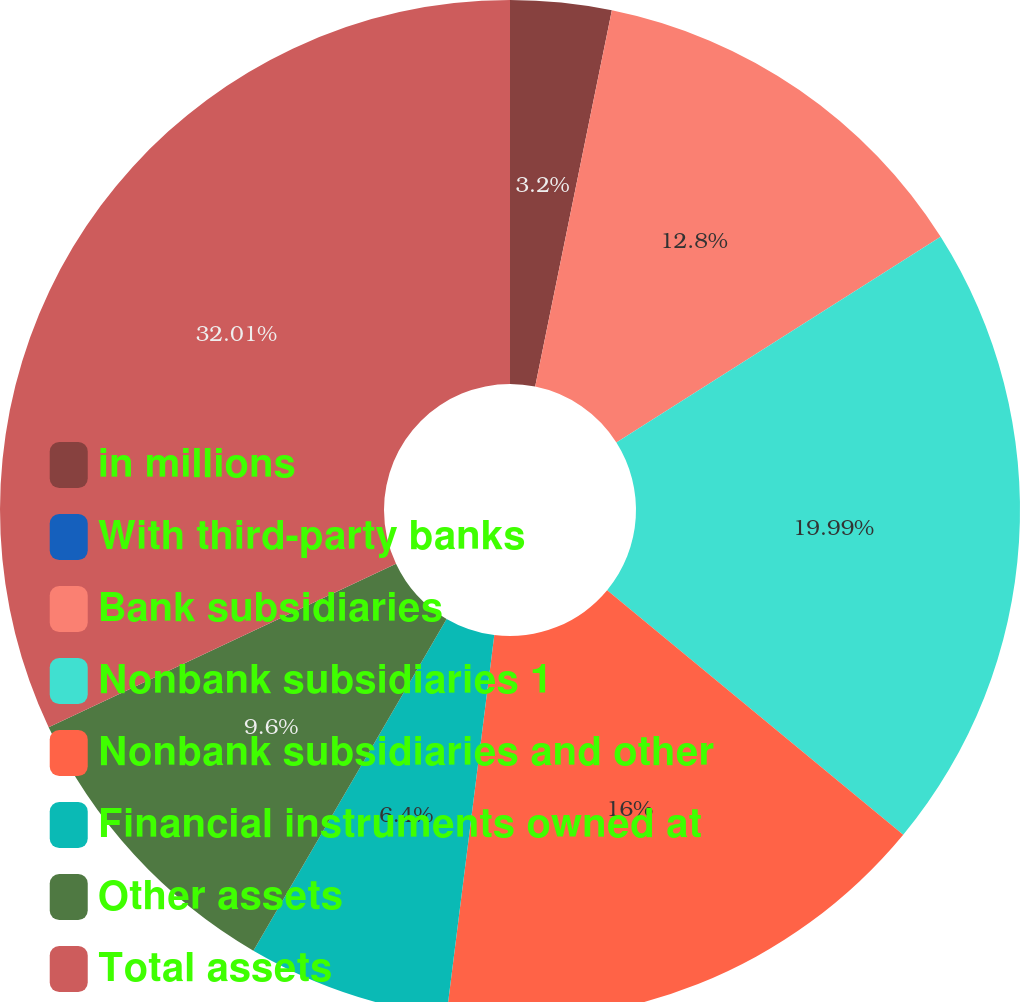Convert chart. <chart><loc_0><loc_0><loc_500><loc_500><pie_chart><fcel>in millions<fcel>With third-party banks<fcel>Bank subsidiaries<fcel>Nonbank subsidiaries 1<fcel>Nonbank subsidiaries and other<fcel>Financial instruments owned at<fcel>Other assets<fcel>Total assets<nl><fcel>3.2%<fcel>0.0%<fcel>12.8%<fcel>19.98%<fcel>16.0%<fcel>6.4%<fcel>9.6%<fcel>32.0%<nl></chart> 